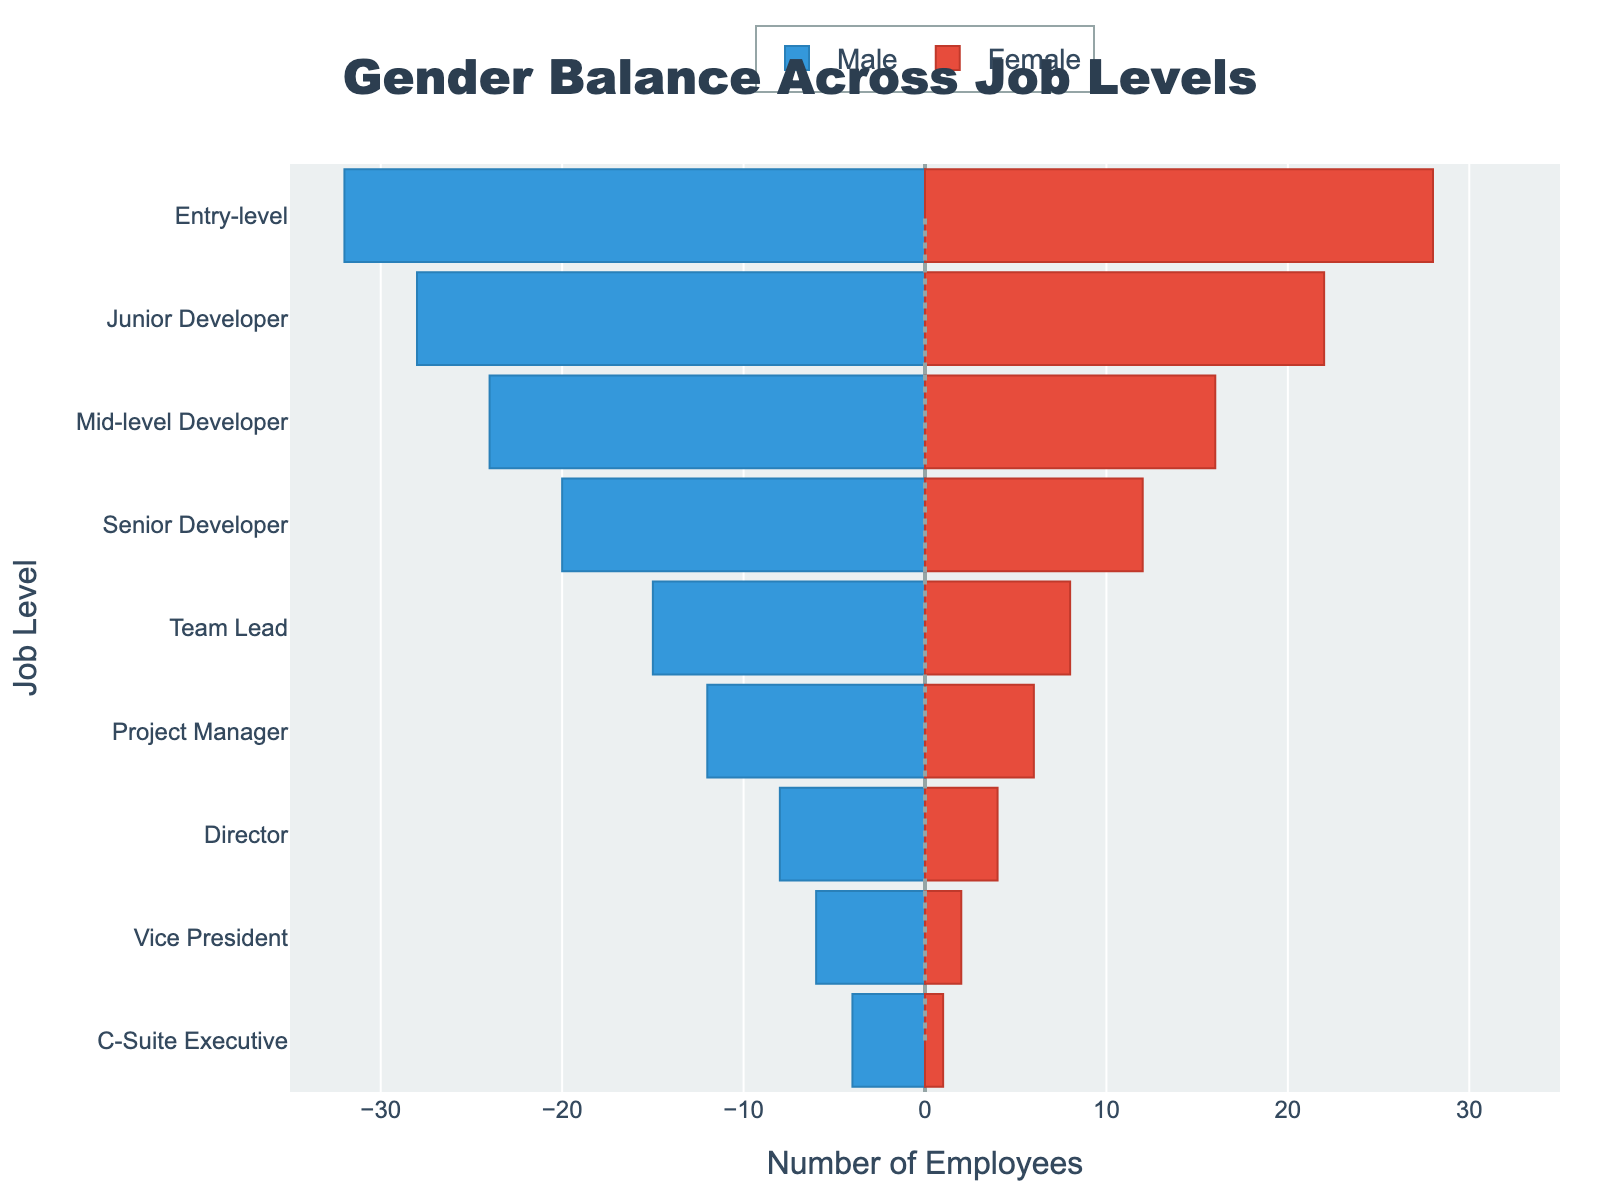what is the title of the figure? The title is typically the main text located at the top of the figure, which in this case is 'Gender Balance Across Job Levels'.
Answer: Gender Balance Across Job Levels what colors are used to represent male and female employees? The colors on the graph represent gender: males are represented by blue bars, and females are represented by red bars.
Answer: Blue for males, red for females how many entry-level male employees are there? On the entry-level bar, the value for males is shown on the negative side of the axis. By reading the label, we see the count is -32 (though the negative sign is purely for visualization).
Answer: 32 compare the number of male and female mid-level developers. From the figure, the number of male mid-level developers is 24, while the number of female mid-level developers is 16.
Answer: 24 males, 16 females which job level shows the most significant gender imbalance? By examining the lengths of the bars, the job level with the most significant difference between male and female employees is the 'C-Suite Executive', where there are 4 males and 1 female.
Answer: C-Suite Executive what is the total number of project managers? Add the number of male and female project managers. From the figure, there are 12 males and 6 females. Therefore, the total is 12 + 6.
Answer: 18 is there any job level where the number of males and females is equal? By examining each pair of bars, there is no job level where both genders have equal numbers.
Answer: No how many more males than females are there at the Director level? From the figure, there are 8 male directors and 4 female directors. The difference is 8 - 4.
Answer: 4 more males which gender has more employees at the entry-level? By comparing the lengths of the entry-level bars, males (32) have more employees than females (28).
Answer: Males 